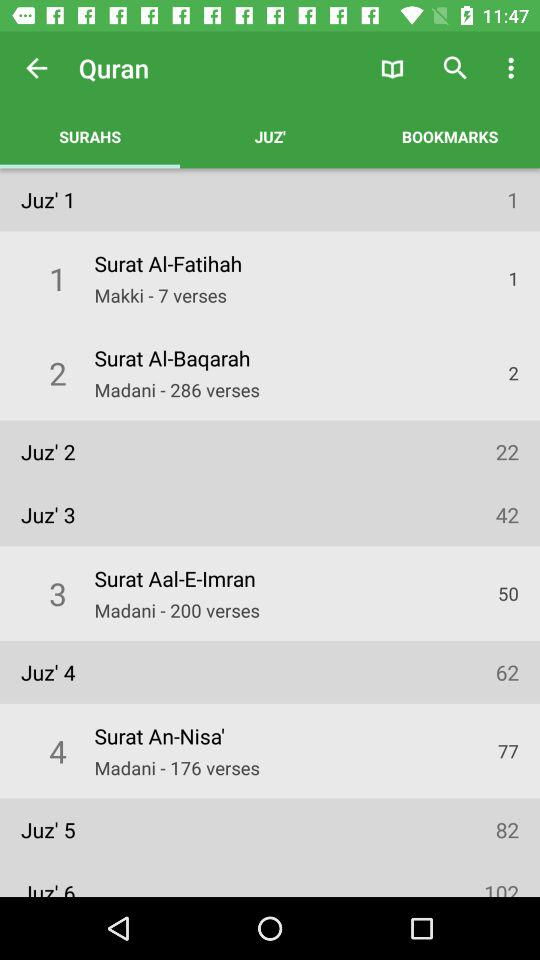Which option is selected in "Quran"? The selected option is "SURAHS". 